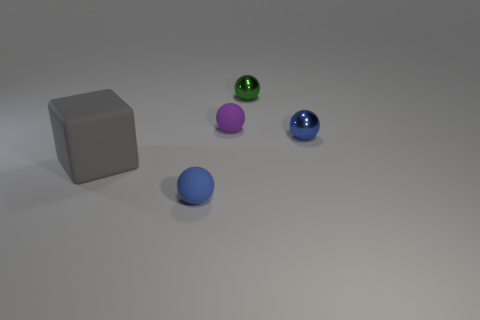Subtract all cyan blocks. Subtract all brown spheres. How many blocks are left? 1 Add 2 blue rubber objects. How many objects exist? 7 Subtract all blocks. How many objects are left? 4 Add 1 rubber blocks. How many rubber blocks exist? 2 Subtract 1 green spheres. How many objects are left? 4 Subtract all green shiny spheres. Subtract all tiny green metal things. How many objects are left? 3 Add 1 gray matte cubes. How many gray matte cubes are left? 2 